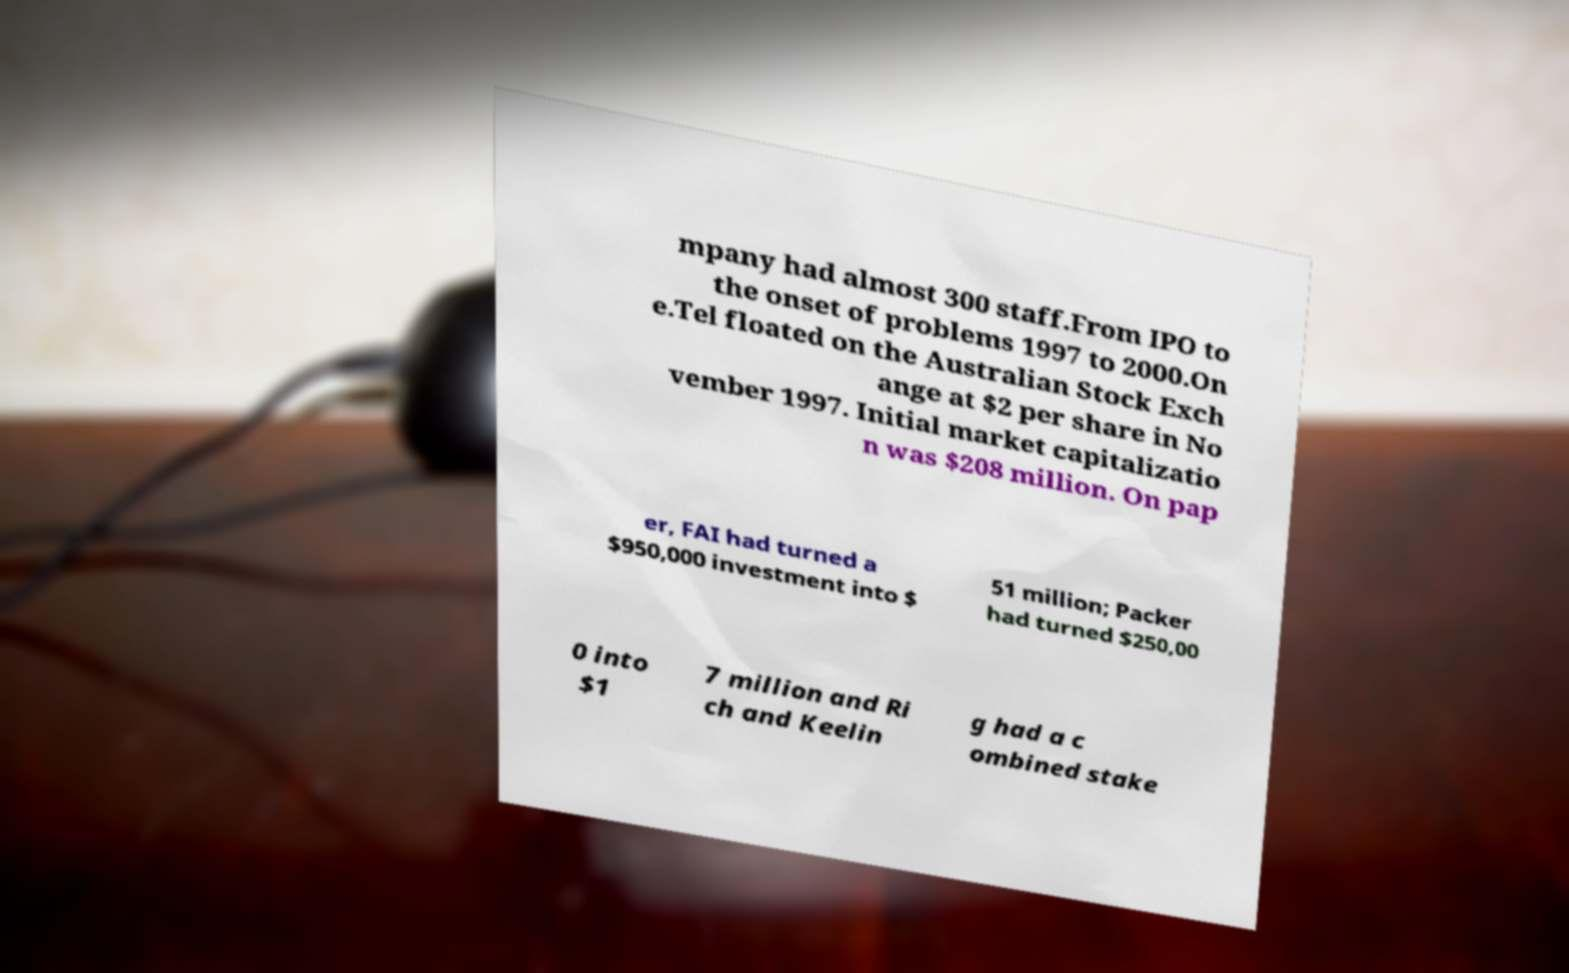What messages or text are displayed in this image? I need them in a readable, typed format. mpany had almost 300 staff.From IPO to the onset of problems 1997 to 2000.On e.Tel floated on the Australian Stock Exch ange at $2 per share in No vember 1997. Initial market capitalizatio n was $208 million. On pap er, FAI had turned a $950,000 investment into $ 51 million; Packer had turned $250,00 0 into $1 7 million and Ri ch and Keelin g had a c ombined stake 